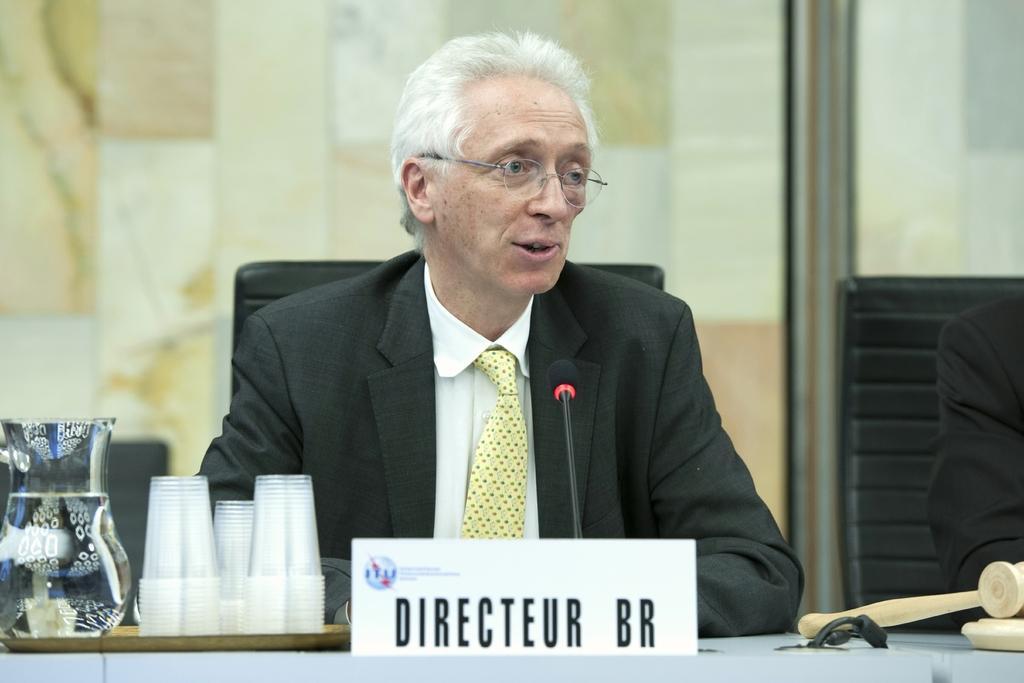Could you give a brief overview of what you see in this image? In this image we can see a man sitting on a chair. In front of the man there is a table with a name plate, microphone, glasses, jar, tray and other objects. On the right side of the image it looks like a person sitting. In the background there is a wall. 